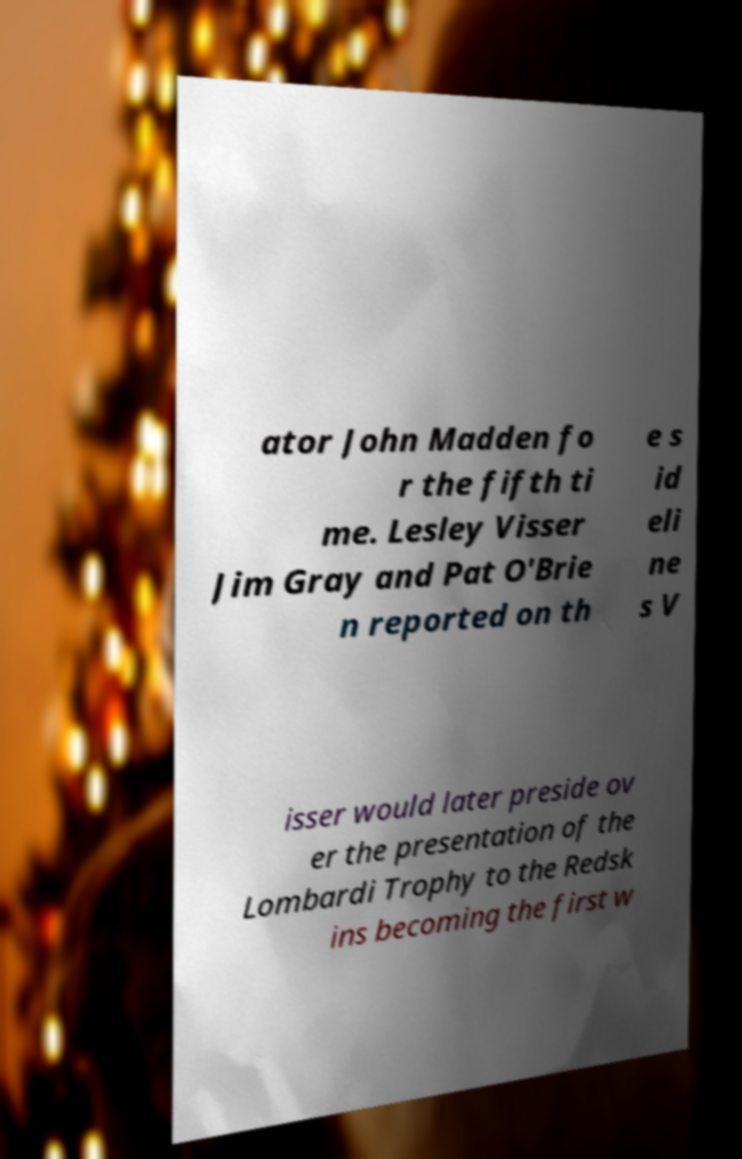Can you accurately transcribe the text from the provided image for me? ator John Madden fo r the fifth ti me. Lesley Visser Jim Gray and Pat O'Brie n reported on th e s id eli ne s V isser would later preside ov er the presentation of the Lombardi Trophy to the Redsk ins becoming the first w 